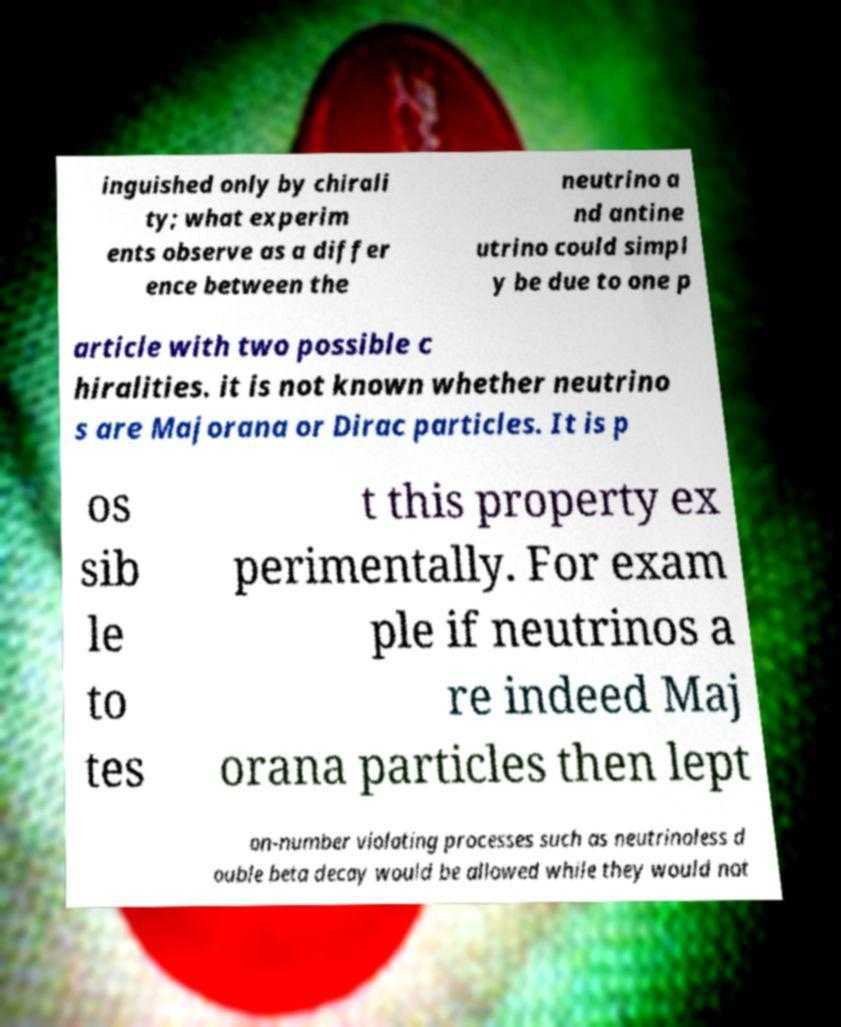For documentation purposes, I need the text within this image transcribed. Could you provide that? inguished only by chirali ty; what experim ents observe as a differ ence between the neutrino a nd antine utrino could simpl y be due to one p article with two possible c hiralities. it is not known whether neutrino s are Majorana or Dirac particles. It is p os sib le to tes t this property ex perimentally. For exam ple if neutrinos a re indeed Maj orana particles then lept on-number violating processes such as neutrinoless d ouble beta decay would be allowed while they would not 